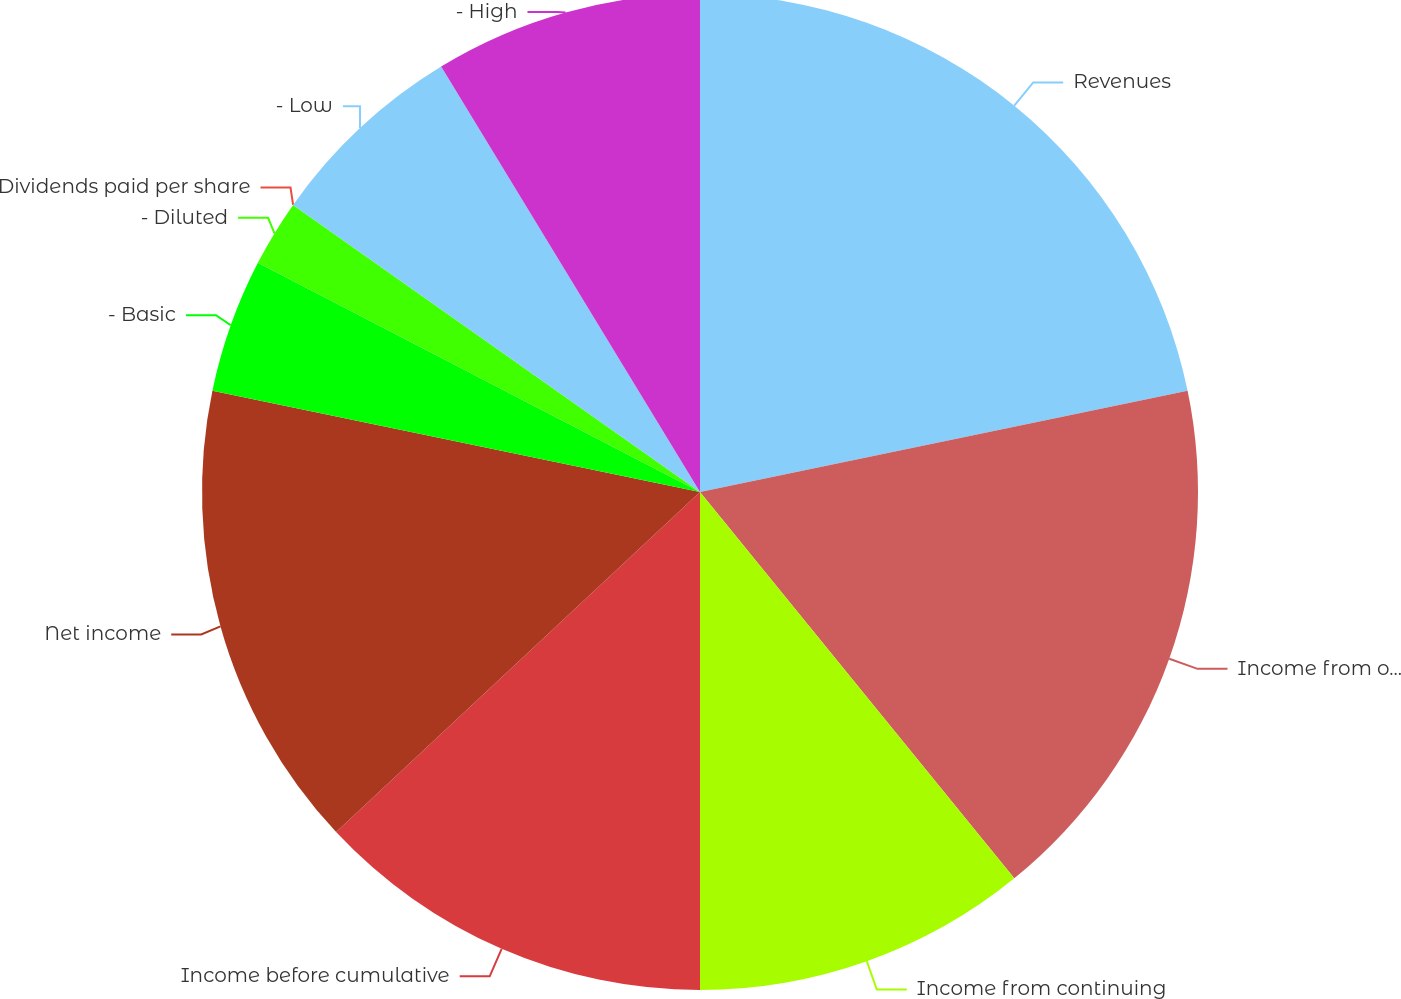Convert chart to OTSL. <chart><loc_0><loc_0><loc_500><loc_500><pie_chart><fcel>Revenues<fcel>Income from operations<fcel>Income from continuing<fcel>Income before cumulative<fcel>Net income<fcel>- Basic<fcel>- Diluted<fcel>Dividends paid per share<fcel>- Low<fcel>- High<nl><fcel>21.74%<fcel>17.39%<fcel>10.87%<fcel>13.04%<fcel>15.22%<fcel>4.35%<fcel>2.17%<fcel>0.0%<fcel>6.52%<fcel>8.7%<nl></chart> 